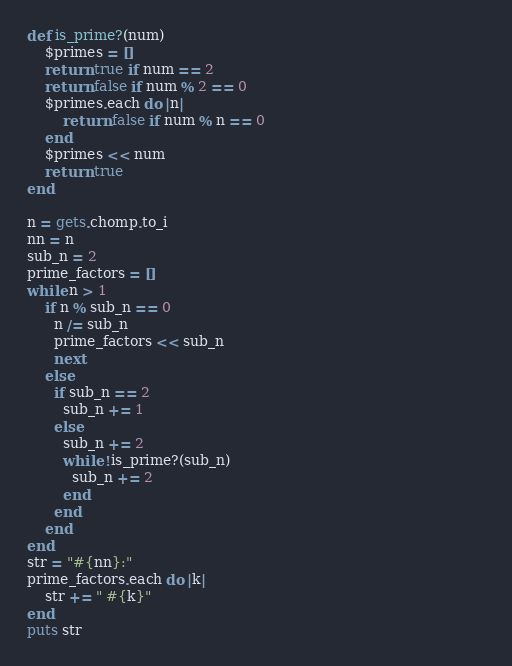Convert code to text. <code><loc_0><loc_0><loc_500><loc_500><_Ruby_>def is_prime?(num)
    $primes = []
    return true if num == 2
    return false if num % 2 == 0
    $primes.each do |n|
        return false if num % n == 0
    end
    $primes << num
    return true
end

n = gets.chomp.to_i
nn = n
sub_n = 2
prime_factors = []
while n > 1
	if n % sub_n == 0
      n /= sub_n
	  prime_factors << sub_n
	  next
	else
      if sub_n == 2
        sub_n += 1
      else
        sub_n += 2
        while !is_prime?(sub_n)
          sub_n += 2
        end
      end
	end
end																								 
str = "#{nn}:"
prime_factors.each do |k|
	str += " #{k}"
end
puts str</code> 